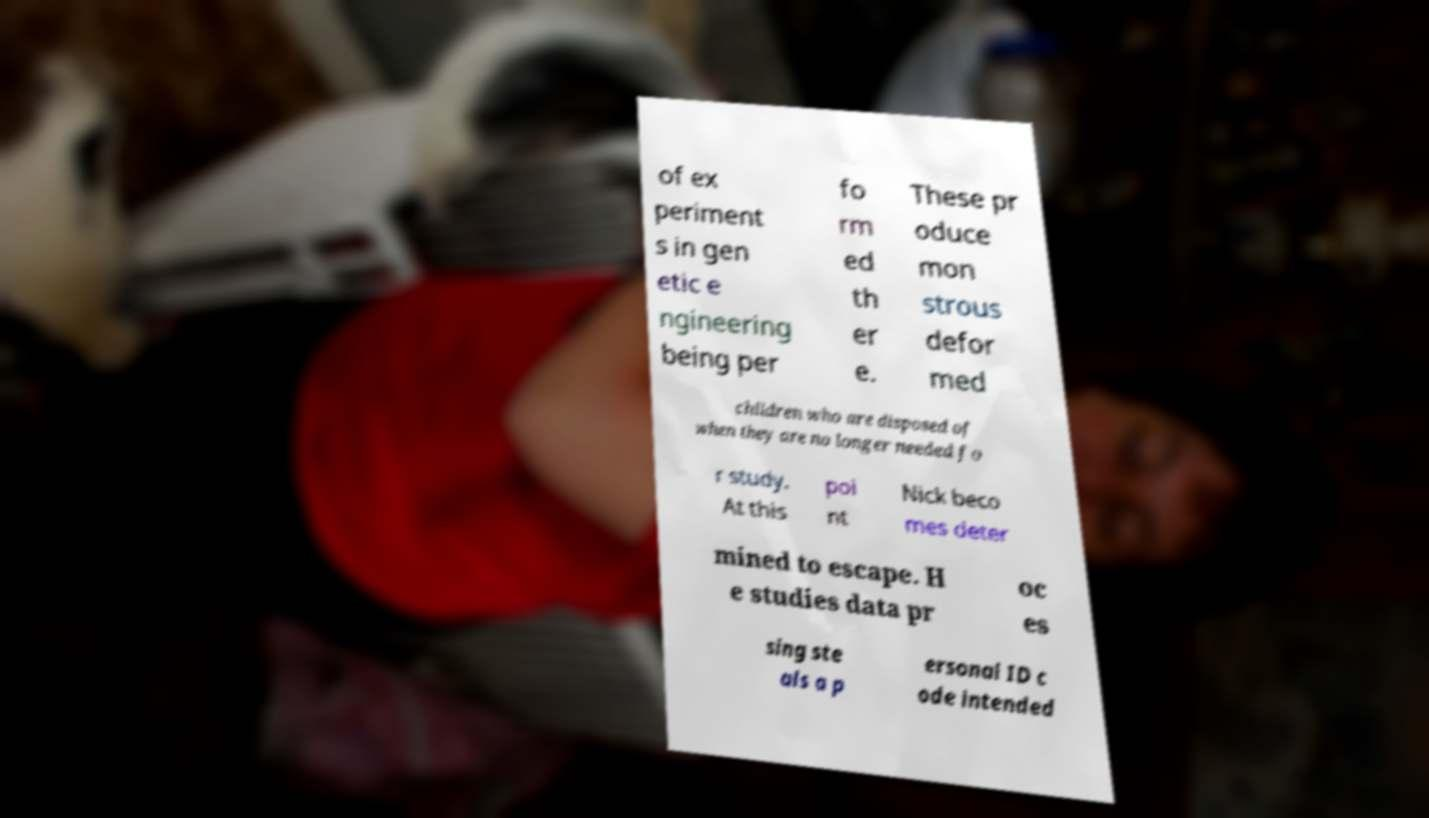Please identify and transcribe the text found in this image. of ex periment s in gen etic e ngineering being per fo rm ed th er e. These pr oduce mon strous defor med children who are disposed of when they are no longer needed fo r study. At this poi nt Nick beco mes deter mined to escape. H e studies data pr oc es sing ste als a p ersonal ID c ode intended 